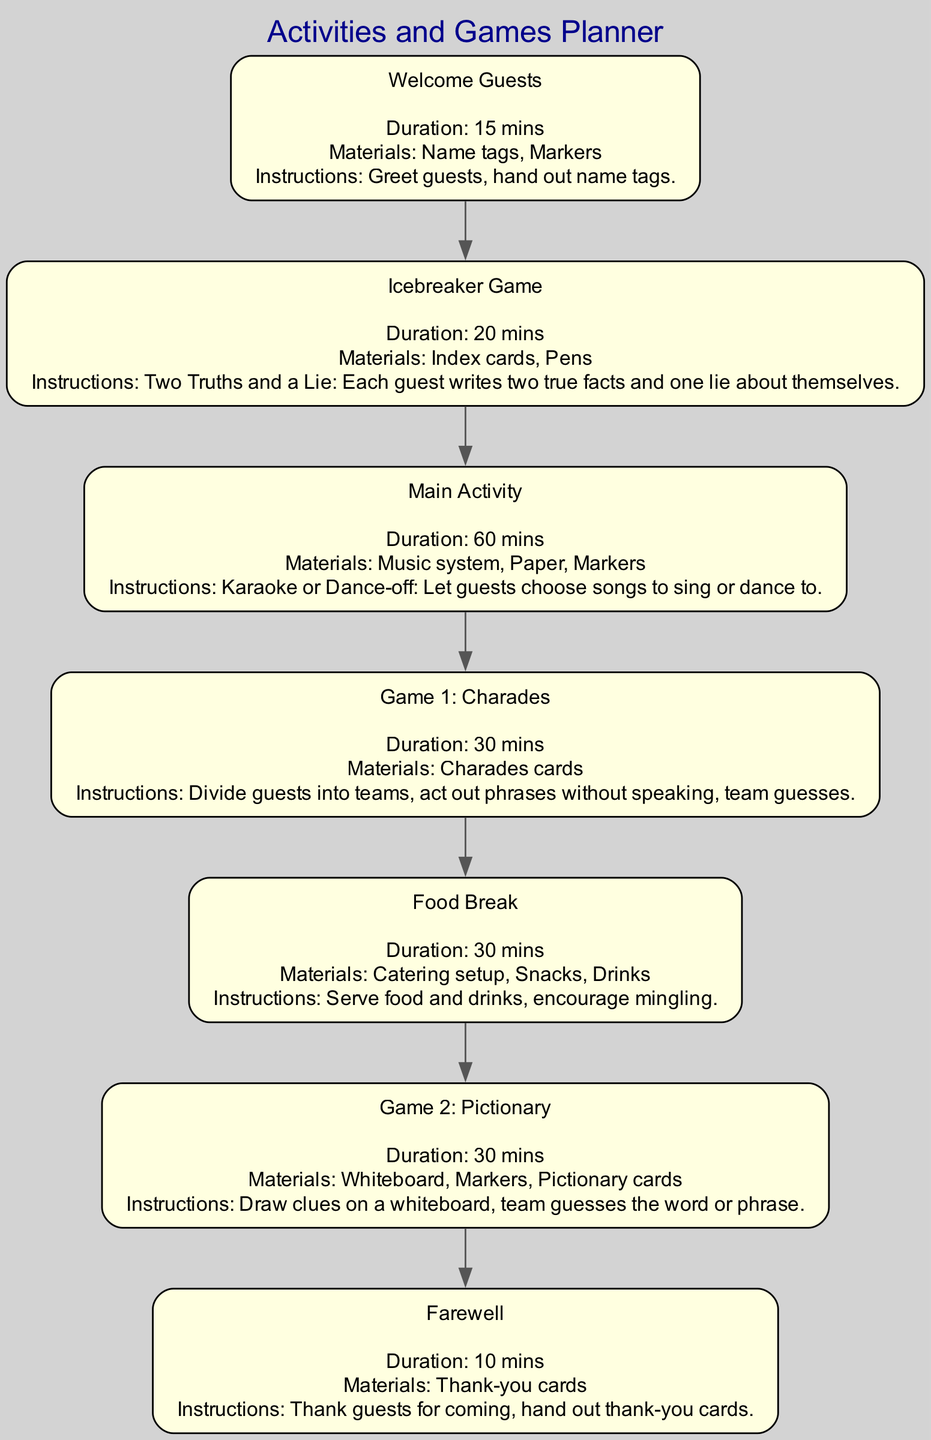What is the first activity in the planner? The diagram shows the nodes in a sequence. The first node is labeled "Welcome Guests," which indicates it is the inaugural activity.
Answer: Welcome Guests How long does the Icebreaker Game last? The details for the "Icebreaker Game" node state its duration is "20 mins." Therefore, we can directly refer to this detail for the answer.
Answer: 20 mins What materials are needed for the Main Activity? By inspecting the node for "Main Activity," it lists "Music system, Paper, Markers" as the materials needed. This information comes directly from the specified details within that node.
Answer: Music system, Paper, Markers How many games are listed in the planner? The diagram shows two distinct games: "Game 1: Charades" and "Game 2: Pictionary." Thus, counting these nodes gives us the total number of games mentioned in the planner.
Answer: 2 What is the last activity that occurs before Farewell? The edge connecting "Game 2" to "end" indicates that "Game 2: Pictionary" is the final activity before the "Farewell" segment in the timeline. This sequential relationship helps identify the answer.
Answer: Game 2: Pictionary What is the duration of the Food Break? The node labeled "Food Break" specifies a duration of "30 mins." This explicit detail provides the information required to answer the question accurately.
Answer: 30 mins What is the total duration of activities before the Food Break? To calculate the total duration before "Food Break," we can add the durations of "Welcome Guests" (15 mins), "Icebreaker Game" (20 mins), "Main Activity" (60 mins), and "Game 1: Charades" (30 mins): 15 + 20 + 60 + 30 = 125 minutes. This aggregate provides a comprehensive view of the activities preceding the break.
Answer: 125 mins What materials are needed in Game 1? The node for "Game 1: Charades" lists "Charades cards" as the only material required for this activity. This straightforward information is found explicitly in the node's details.
Answer: Charades cards 